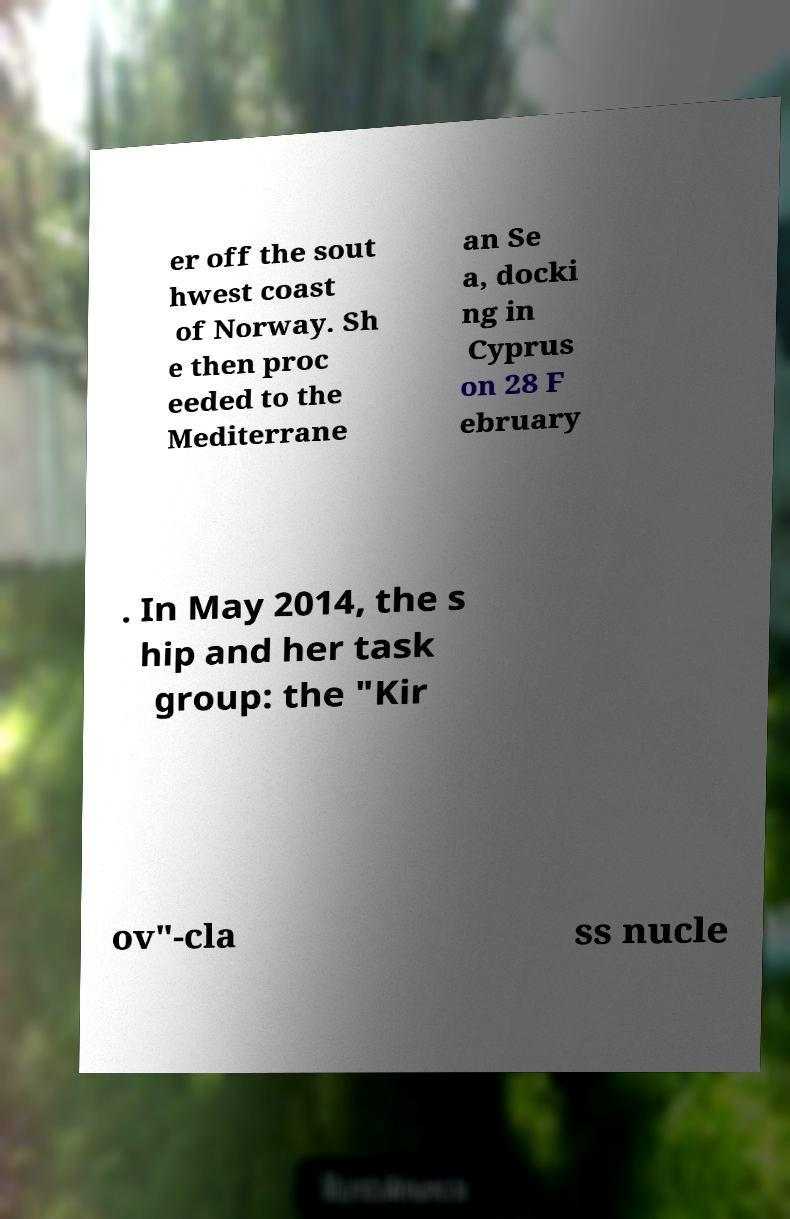Can you accurately transcribe the text from the provided image for me? er off the sout hwest coast of Norway. Sh e then proc eeded to the Mediterrane an Se a, docki ng in Cyprus on 28 F ebruary . In May 2014, the s hip and her task group: the "Kir ov"-cla ss nucle 